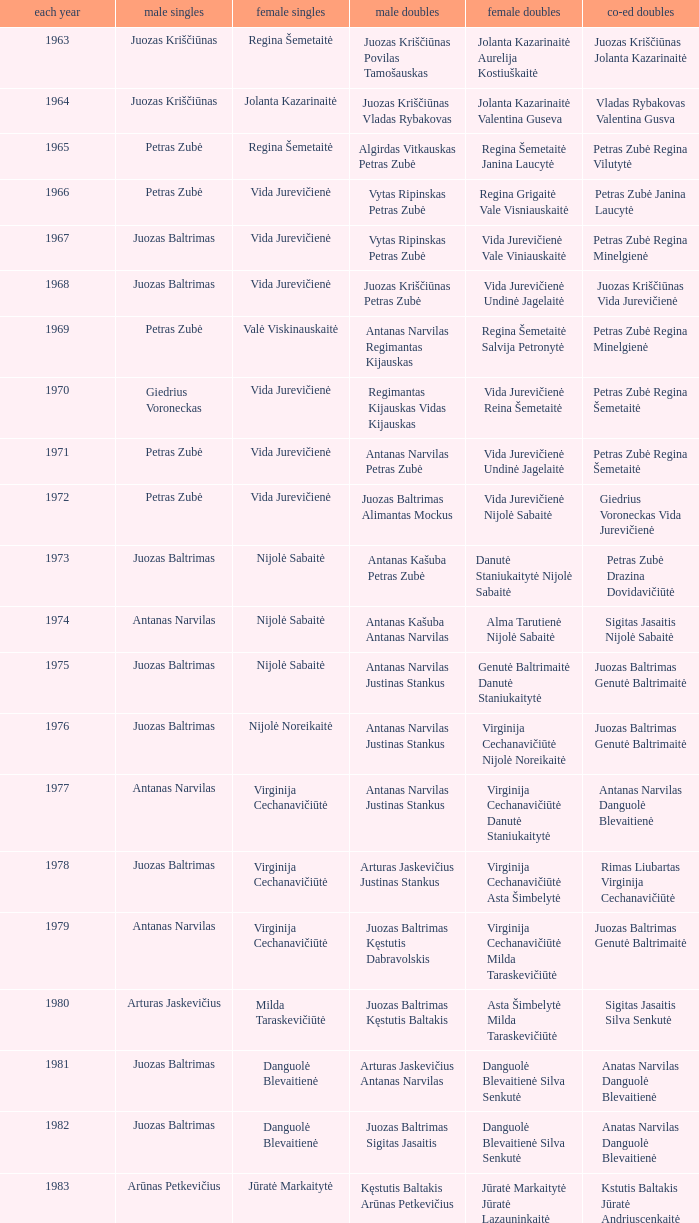How many years did aivaras kvedarauskas juozas spelveris participate in the men's doubles? 1.0. Help me parse the entirety of this table. {'header': ['each year', 'male singles', 'female singles', 'male doubles', 'female doubles', 'co-ed doubles'], 'rows': [['1963', 'Juozas Kriščiūnas', 'Regina Šemetaitė', 'Juozas Kriščiūnas Povilas Tamošauskas', 'Jolanta Kazarinaitė Aurelija Kostiuškaitė', 'Juozas Kriščiūnas Jolanta Kazarinaitė'], ['1964', 'Juozas Kriščiūnas', 'Jolanta Kazarinaitė', 'Juozas Kriščiūnas Vladas Rybakovas', 'Jolanta Kazarinaitė Valentina Guseva', 'Vladas Rybakovas Valentina Gusva'], ['1965', 'Petras Zubė', 'Regina Šemetaitė', 'Algirdas Vitkauskas Petras Zubė', 'Regina Šemetaitė Janina Laucytė', 'Petras Zubė Regina Vilutytė'], ['1966', 'Petras Zubė', 'Vida Jurevičienė', 'Vytas Ripinskas Petras Zubė', 'Regina Grigaitė Vale Visniauskaitė', 'Petras Zubė Janina Laucytė'], ['1967', 'Juozas Baltrimas', 'Vida Jurevičienė', 'Vytas Ripinskas Petras Zubė', 'Vida Jurevičienė Vale Viniauskaitė', 'Petras Zubė Regina Minelgienė'], ['1968', 'Juozas Baltrimas', 'Vida Jurevičienė', 'Juozas Kriščiūnas Petras Zubė', 'Vida Jurevičienė Undinė Jagelaitė', 'Juozas Kriščiūnas Vida Jurevičienė'], ['1969', 'Petras Zubė', 'Valė Viskinauskaitė', 'Antanas Narvilas Regimantas Kijauskas', 'Regina Šemetaitė Salvija Petronytė', 'Petras Zubė Regina Minelgienė'], ['1970', 'Giedrius Voroneckas', 'Vida Jurevičienė', 'Regimantas Kijauskas Vidas Kijauskas', 'Vida Jurevičienė Reina Šemetaitė', 'Petras Zubė Regina Šemetaitė'], ['1971', 'Petras Zubė', 'Vida Jurevičienė', 'Antanas Narvilas Petras Zubė', 'Vida Jurevičienė Undinė Jagelaitė', 'Petras Zubė Regina Šemetaitė'], ['1972', 'Petras Zubė', 'Vida Jurevičienė', 'Juozas Baltrimas Alimantas Mockus', 'Vida Jurevičienė Nijolė Sabaitė', 'Giedrius Voroneckas Vida Jurevičienė'], ['1973', 'Juozas Baltrimas', 'Nijolė Sabaitė', 'Antanas Kašuba Petras Zubė', 'Danutė Staniukaitytė Nijolė Sabaitė', 'Petras Zubė Drazina Dovidavičiūtė'], ['1974', 'Antanas Narvilas', 'Nijolė Sabaitė', 'Antanas Kašuba Antanas Narvilas', 'Alma Tarutienė Nijolė Sabaitė', 'Sigitas Jasaitis Nijolė Sabaitė'], ['1975', 'Juozas Baltrimas', 'Nijolė Sabaitė', 'Antanas Narvilas Justinas Stankus', 'Genutė Baltrimaitė Danutė Staniukaitytė', 'Juozas Baltrimas Genutė Baltrimaitė'], ['1976', 'Juozas Baltrimas', 'Nijolė Noreikaitė', 'Antanas Narvilas Justinas Stankus', 'Virginija Cechanavičiūtė Nijolė Noreikaitė', 'Juozas Baltrimas Genutė Baltrimaitė'], ['1977', 'Antanas Narvilas', 'Virginija Cechanavičiūtė', 'Antanas Narvilas Justinas Stankus', 'Virginija Cechanavičiūtė Danutė Staniukaitytė', 'Antanas Narvilas Danguolė Blevaitienė'], ['1978', 'Juozas Baltrimas', 'Virginija Cechanavičiūtė', 'Arturas Jaskevičius Justinas Stankus', 'Virginija Cechanavičiūtė Asta Šimbelytė', 'Rimas Liubartas Virginija Cechanavičiūtė'], ['1979', 'Antanas Narvilas', 'Virginija Cechanavičiūtė', 'Juozas Baltrimas Kęstutis Dabravolskis', 'Virginija Cechanavičiūtė Milda Taraskevičiūtė', 'Juozas Baltrimas Genutė Baltrimaitė'], ['1980', 'Arturas Jaskevičius', 'Milda Taraskevičiūtė', 'Juozas Baltrimas Kęstutis Baltakis', 'Asta Šimbelytė Milda Taraskevičiūtė', 'Sigitas Jasaitis Silva Senkutė'], ['1981', 'Juozas Baltrimas', 'Danguolė Blevaitienė', 'Arturas Jaskevičius Antanas Narvilas', 'Danguolė Blevaitienė Silva Senkutė', 'Anatas Narvilas Danguolė Blevaitienė'], ['1982', 'Juozas Baltrimas', 'Danguolė Blevaitienė', 'Juozas Baltrimas Sigitas Jasaitis', 'Danguolė Blevaitienė Silva Senkutė', 'Anatas Narvilas Danguolė Blevaitienė'], ['1983', 'Arūnas Petkevičius', 'Jūratė Markaitytė', 'Kęstutis Baltakis Arūnas Petkevičius', 'Jūratė Markaitytė Jūratė Lazauninkaitė', 'Kstutis Baltakis Jūratė Andriuscenkaitė'], ['1984', 'Arūnas Petkevičius', 'Jūratė Markaitytė', 'Kęstutis Baltakis Arūnas Petkevičius', 'Jūratė Markaitytė Edita Andriuscenkaitė', 'Arūnas Petkevičius Jūratė Markaitytė'], ['1985', 'Arūnas Petkevičius', 'Jūratė Markaitytė', 'Kęstutis Baltakis Arūnas Petkevičius', 'Jūratė Markaitytė Silva Senkutė', 'Arūnas Petkevičius Jūratė Markaitytė'], ['1986', 'Arūnas Petkevičius', 'Jūratė Markaitytė', 'Kęstutis Baltakis Arūnas Petkevičius', 'Jūratė Markaitytė Aušrinė Gebranaitė', 'Egidijus Jankauskas Jūratė Markaitytė'], ['1987', 'Egidijus Jankauskas', 'Jūratė Markaitytė', 'Kęstutis Baltakis Arūnas Petkevičius', 'Jūratė Markaitytė Danguolė Blevaitienė', 'Egidijus Jankauskas Danguolė Blevaitienė'], ['1988', 'Arūnas Petkevičius', 'Rasa Mikšytė', 'Algirdas Kepežinskas Ovidius Česonis', 'Jūratė Markaitytė Danguolė Blevaitienė', 'Arūnas Petkevičius Danguolė Blevaitienė'], ['1989', 'Ovidijus Cesonis', 'Aušrinė Gabrenaitė', 'Egidijus Jankauskus Ovidius Česonis', 'Aušrinė Gebranaitė Rasa Mikšytė', 'Egidijus Jankauskas Aušrinė Gabrenaitė'], ['1990', 'Aivaras Kvedarauskas', 'Rasa Mikšytė', 'Algirdas Kepežinskas Ovidius Česonis', 'Jūratė Markaitytė Danguolė Blevaitienė', 'Aivaras Kvedarauskas Rasa Mikšytė'], ['1991', 'Egidius Jankauskas', 'Rasa Mikšytė', 'Egidijus Jankauskus Ovidius Česonis', 'Rasa Mikšytė Solveiga Stasaitytė', 'Algirdas Kepežinskas Rasa Mikšytė'], ['1992', 'Egidius Jankauskas', 'Rasa Mikšytė', 'Aivaras Kvedarauskas Vygandas Virzintas', 'Rasa Mikšytė Solveiga Stasaitytė', 'Algirdas Kepežinskas Rasa Mikšytė'], ['1993', 'Edigius Jankauskas', 'Solveiga Stasaitytė', 'Edigius Jankauskas Aivaras Kvedarauskas', 'Rasa Mikšytė Solveiga Stasaitytė', 'Edigius Jankauskas Solveiga Stasaitytė'], ['1994', 'Aivaras Kvedarauskas', 'Aina Kravtienė', 'Aivaras Kvedarauskas Ovidijus Zukauskas', 'Indre Ivanauskaitė Rasa Mikšytė', 'Aivaras Kvedarauskas Indze Ivanauskaitė'], ['1995', 'Aivaras Kvedarauskas', 'Rasa Mikšytė', 'Algirdas Kepežinskas Aivaras Kvedarauskas', 'Indre Ivanauskaitė Rasa Mikšytė', 'Aivaras Kvedarauskas Rasa Mikšytė'], ['1996', 'Aivaras Kvedarauskas', 'Rasa Myksite', 'Aivaras Kvedarauskas Donatas Vievesis', 'Indre Ivanauskaitė Rasa Mikšytė', 'Aivaras Kvedarauskas Rasa Mikšytė'], ['1997', 'Aivaras Kvedarauskas', 'Rasa Myksite', 'Aivaras Kvedarauskas Gediminas Andrikonis', 'Neringa Karosaitė Aina Kravtienė', 'Aivaras Kvedarauskas Rasa Mikšytė'], ['1998', 'Aivaras Kvedarauskas', 'Neringa Karosaitė', 'Aivaras Kvedarauskas Dainius Mikalauskas', 'Rasa Mikšytė Jūratė Prevelienė', 'Aivaras Kvedarauskas Jūratė Prevelienė'], ['1999', 'Aivaras Kvedarauskas', 'Erika Milikauskaitė', 'Aivaras Kvedarauskas Dainius Mikalauskas', 'Rasa Mikšytė Jūratė Prevelienė', 'Aivaras Kvedarauskas Rasa Mikšytė'], ['2000', 'Aivaras Kvedarauskas', 'Erika Milikauskaitė', 'Aivaras Kvedarauskas Donatas Vievesis', 'Kristina Dovidaitytė Neringa Karosaitė', 'Aivaras Kvedarauskas Jūratė Prevelienė'], ['2001', 'Aivaras Kvedarauskas', 'Neringa Karosaitė', 'Aivaras Kvedarauskas Juozas Spelveris', 'Kristina Dovidaitytė Neringa Karosaitė', 'Aivaras Kvedarauskas Ligita Zakauskaitė'], ['2002', 'Aivaras Kvedarauskas', 'Erika Milikauskaitė', 'Aivaras Kvedarauskas Kęstutis Navickas', 'Kristina Dovidaitytė Neringa Karosaitė', 'Aivaras Kvedarauskas Jūratė Prevelienė'], ['2003', 'Aivaras Kvedarauskas', 'Ugnė Urbonaitė', 'Aivaras Kvedarauskas Dainius Mikalauskas', 'Ugnė Urbonaitė Kristina Dovidaitytė', 'Aivaras Kvedarauskas Ugnė Urbonaitė'], ['2004', 'Kęstutis Navickas', 'Ugnė Urbonaitė', 'Kęstutis Navickas Klaudijus Kasinskis', 'Ugnė Urbonaitė Akvilė Stapušaitytė', 'Kęstutis Navickas Ugnė Urbonaitė'], ['2005', 'Kęstutis Navickas', 'Ugnė Urbonaitė', 'Kęstutis Navickas Klaudijus Kasinskis', 'Ugnė Urbonaitė Akvilė Stapušaitytė', 'Donatas Narvilas Kristina Dovidaitytė'], ['2006', 'Šarūnas Bilius', 'Akvilė Stapušaitytė', 'Deividas Butkus Klaudijus Kašinskis', 'Akvilė Stapušaitytė Ligita Žukauskaitė', 'Donatas Narvilas Kristina Dovidaitytė'], ['2007', 'Kęstutis Navickas', 'Akvilė Stapušaitytė', 'Kęstutis Navickas Klaudijus Kašinskis', 'Gerda Voitechovskaja Kristina Dovidaitytė', 'Kęstutis Navickas Indrė Starevičiūtė'], ['2008', 'Kęstutis Navickas', 'Akvilė Stapušaitytė', 'Paulius Geležiūnas Ramūnas Stapušaitis', 'Gerda Voitechovskaja Kristina Dovidaitytė', 'Kęstutis Navickas Akvilė Stapušaitytė'], ['2009', 'Kęstutis Navickas', 'Akvilė Stapušaitytė', 'Kęstutis Navickas Klaudijus Kašinskis', 'Akvilė Stapušaitytė Ligita Žukauskaitė', 'Kęstutis Navickas Akvilė Stapušaitytė']]} 